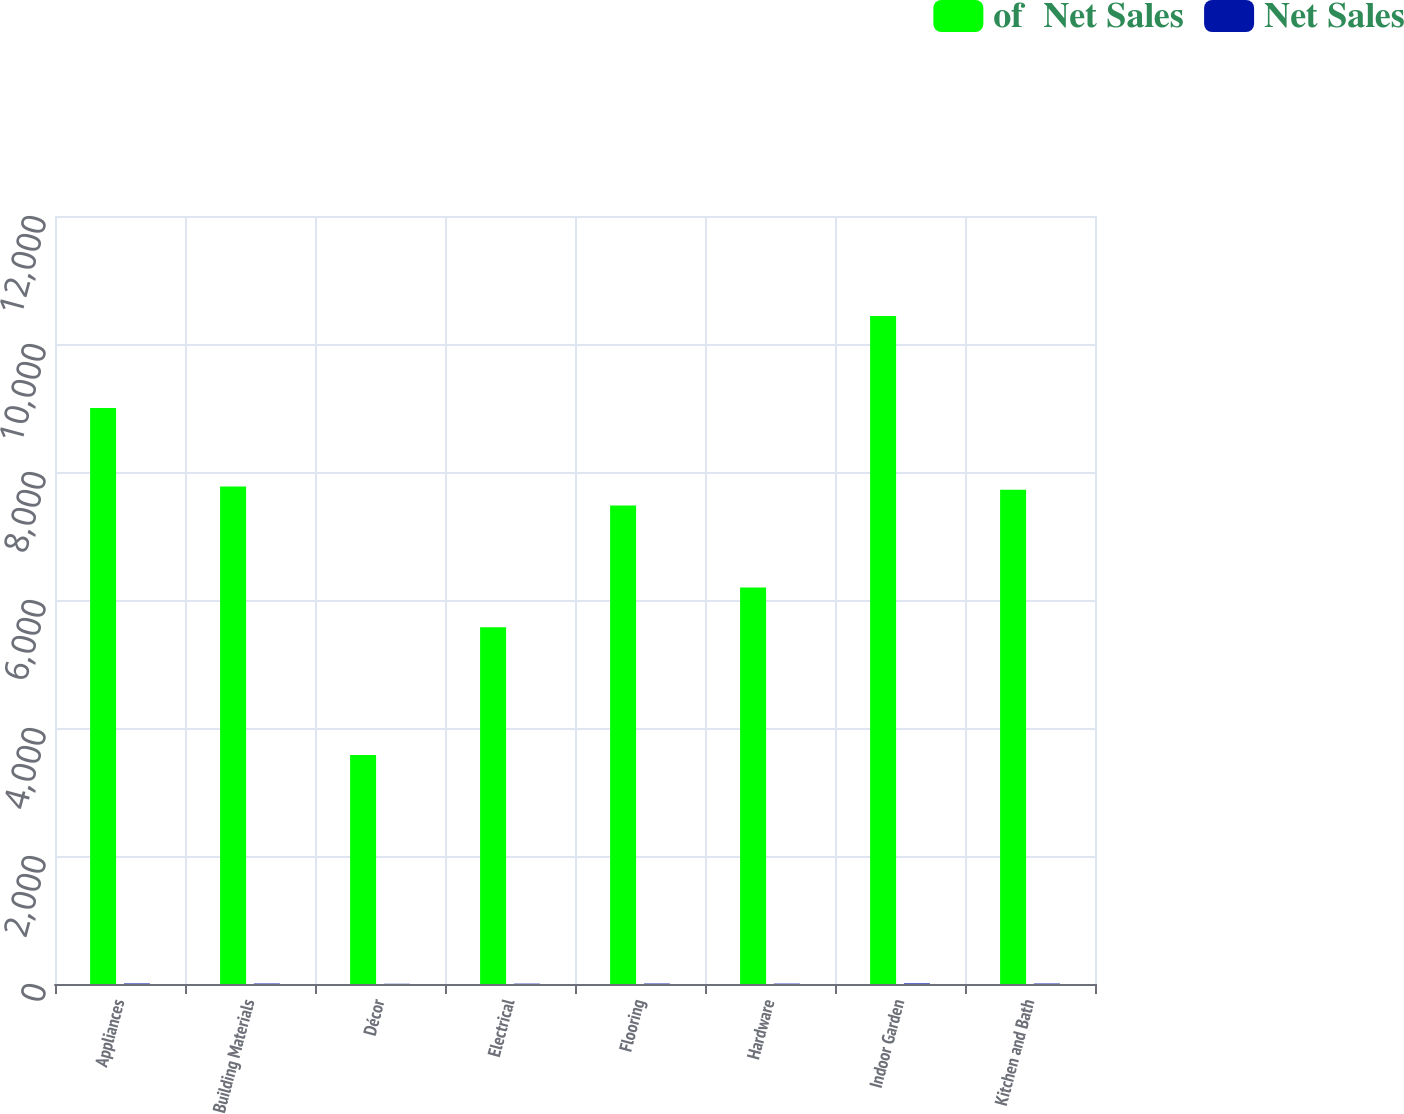Convert chart. <chart><loc_0><loc_0><loc_500><loc_500><stacked_bar_chart><ecel><fcel>Appliances<fcel>Building Materials<fcel>Décor<fcel>Electrical<fcel>Flooring<fcel>Hardware<fcel>Indoor Garden<fcel>Kitchen and Bath<nl><fcel>of  Net Sales<fcel>9001<fcel>7772<fcel>3580<fcel>5576<fcel>7475<fcel>6194<fcel>10438<fcel>7721<nl><fcel>Net Sales<fcel>8.3<fcel>7.2<fcel>3.3<fcel>5.2<fcel>6.9<fcel>5.7<fcel>9.6<fcel>7.1<nl></chart> 